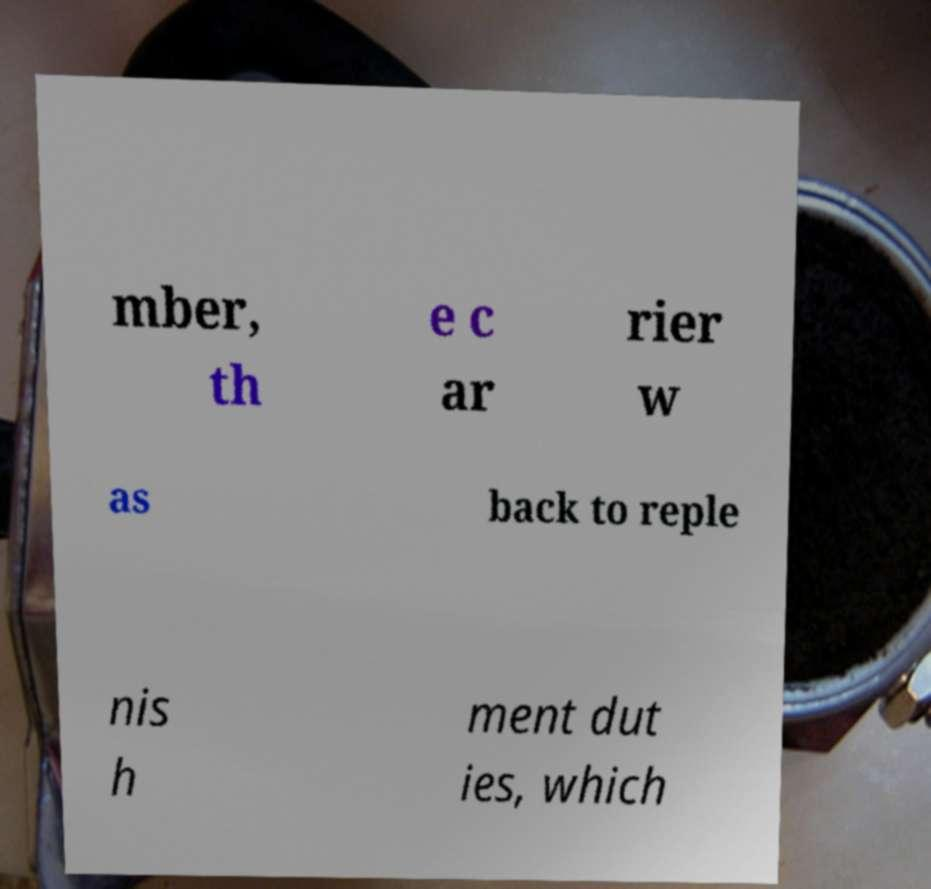Can you read and provide the text displayed in the image?This photo seems to have some interesting text. Can you extract and type it out for me? mber, th e c ar rier w as back to reple nis h ment dut ies, which 